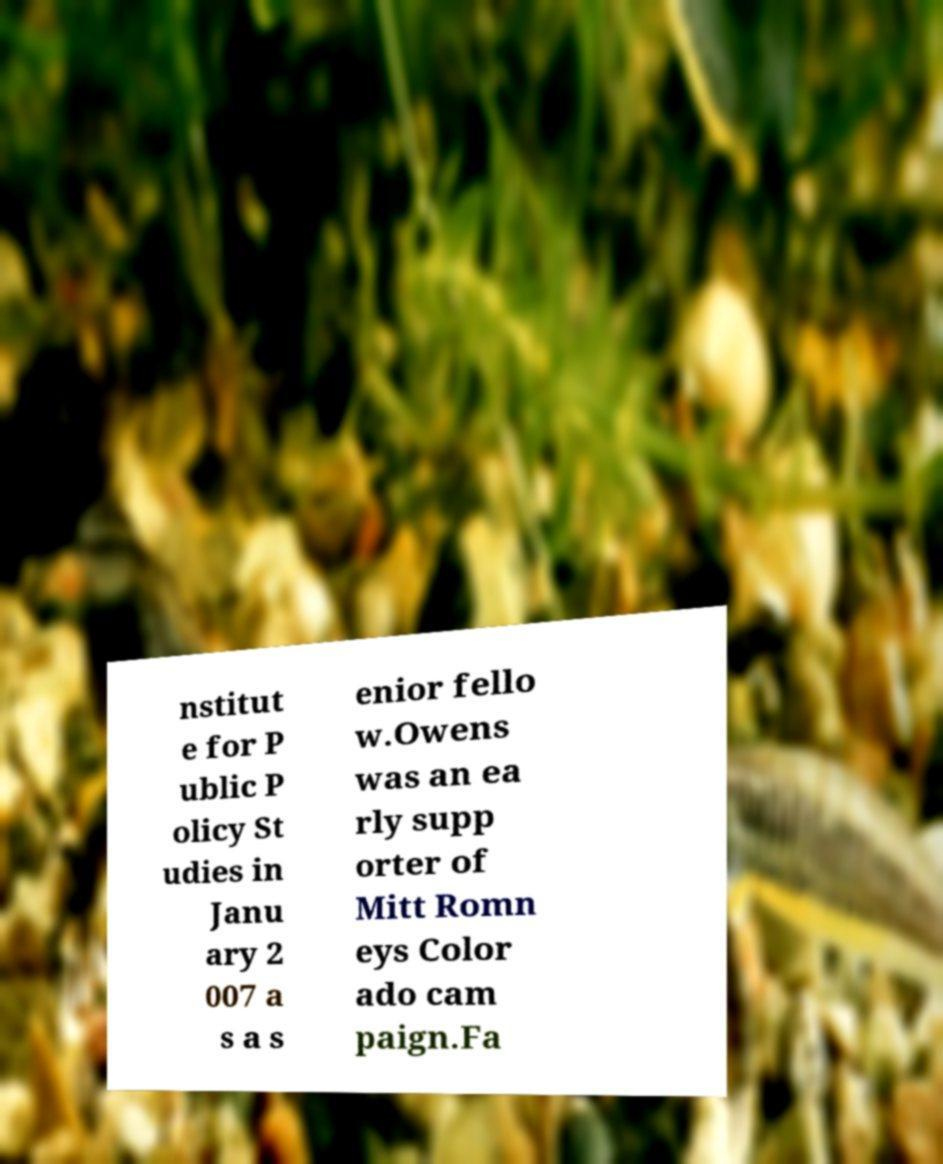There's text embedded in this image that I need extracted. Can you transcribe it verbatim? nstitut e for P ublic P olicy St udies in Janu ary 2 007 a s a s enior fello w.Owens was an ea rly supp orter of Mitt Romn eys Color ado cam paign.Fa 